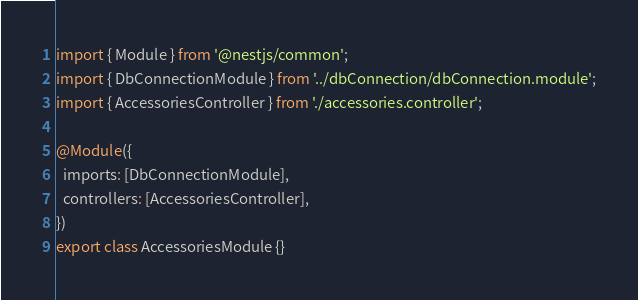Convert code to text. <code><loc_0><loc_0><loc_500><loc_500><_TypeScript_>import { Module } from '@nestjs/common';
import { DbConnectionModule } from '../dbConnection/dbConnection.module';
import { AccessoriesController } from './accessories.controller';

@Module({
  imports: [DbConnectionModule],
  controllers: [AccessoriesController],
})
export class AccessoriesModule {}
</code> 